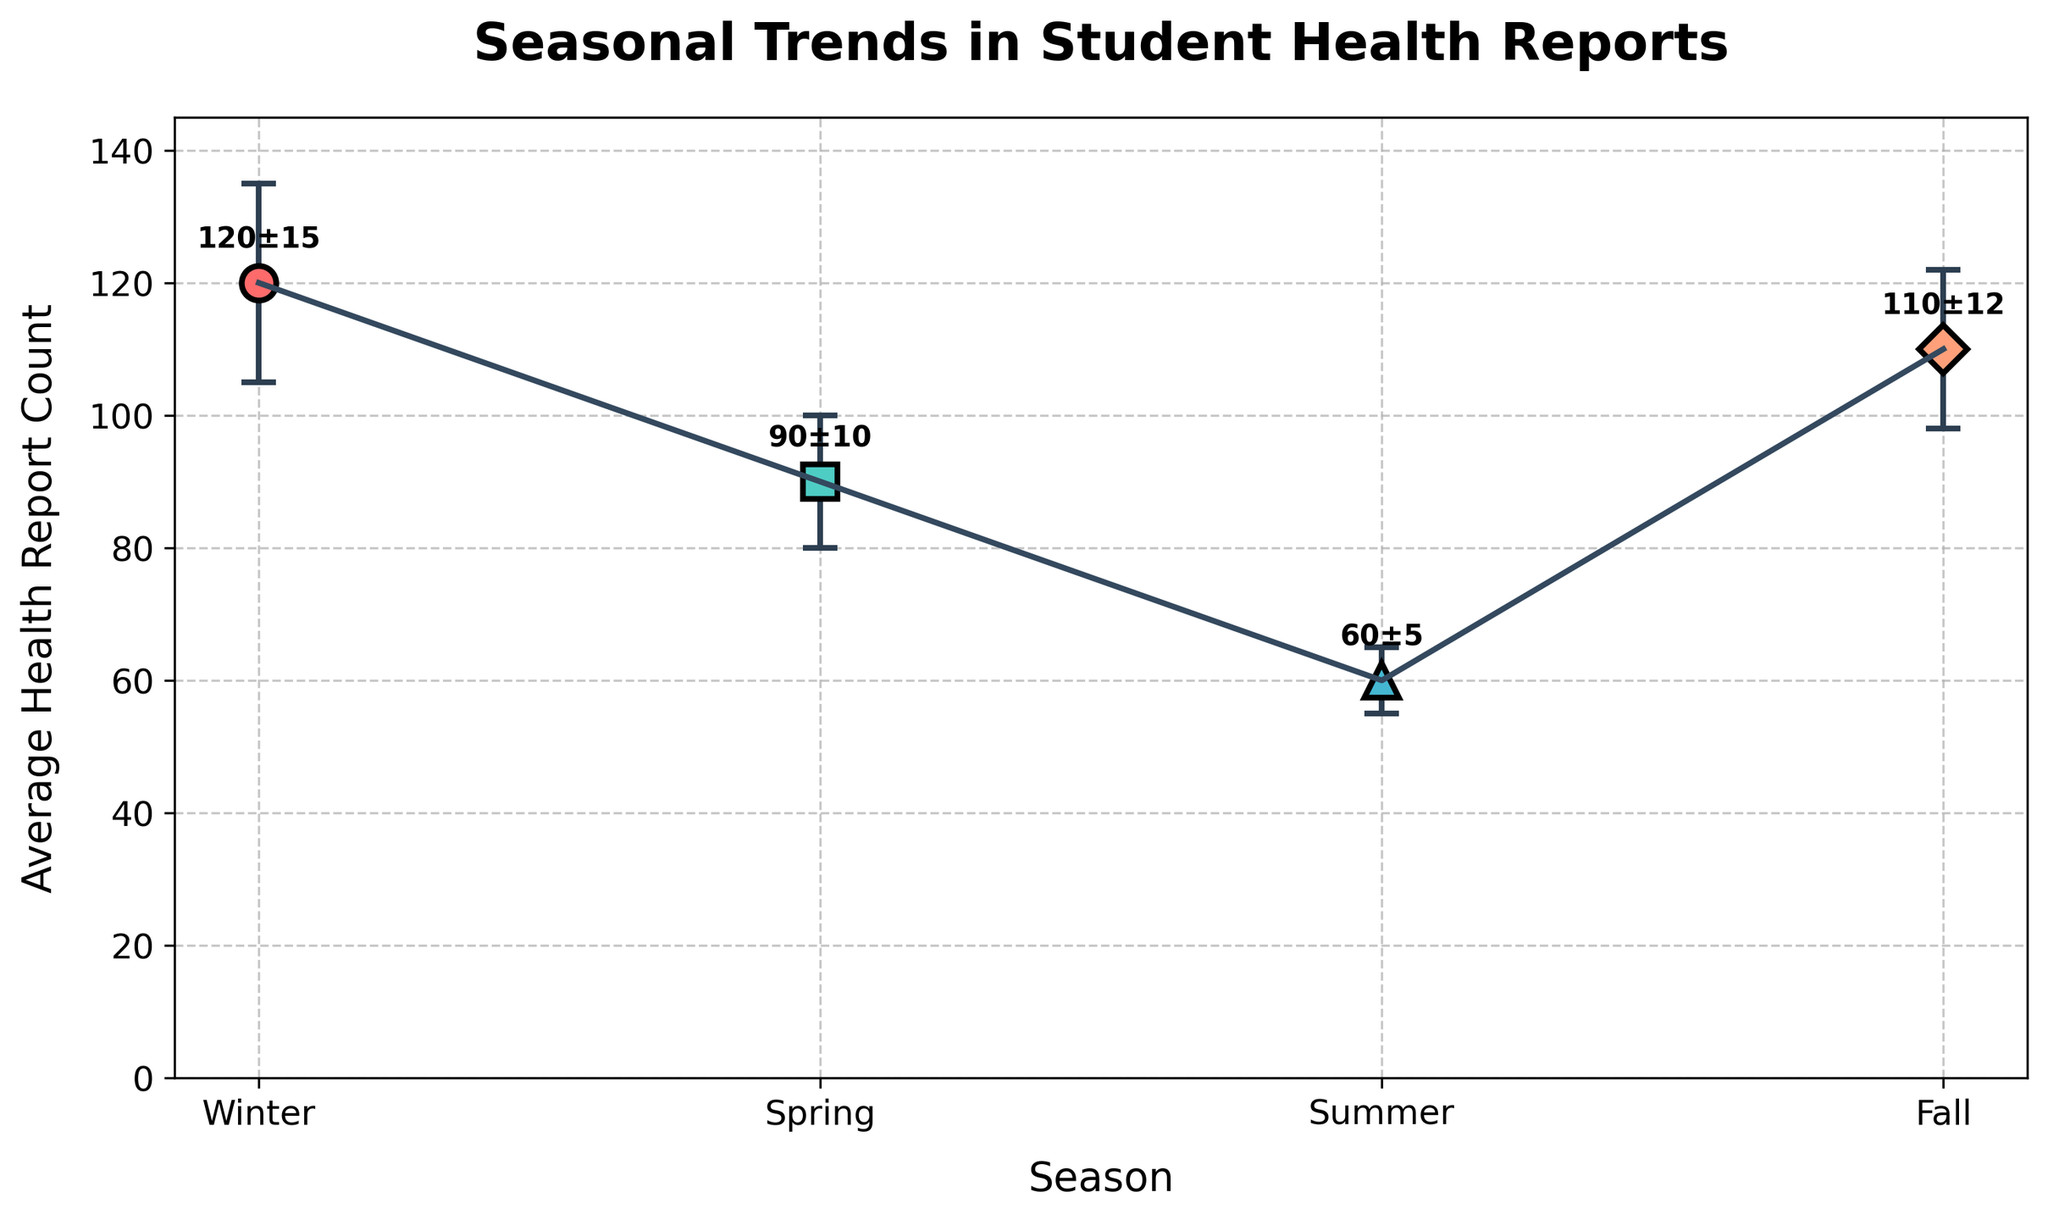What is the title of the figure? The title of the figure is usually located at the top, and in this case, it is "Seasonal Trends in Student Health Reports".
Answer: Seasonal Trends in Student Health Reports What season has the highest average health report count? By examining the points on the vertical axis, we see that Winter has the highest point at 120.
Answer: Winter How much variability (error bar) is there in the Spring season? The vertical error bar line coming from the Spring point indicates how much it varies, which is 10.
Answer: 10 Which season has the smallest average health report count? The lowest point on the vertical axis represents the season with the smallest count. For this plot, it is Summer at 60.
Answer: Summer Arrange the seasons in order of average health report count, from highest to lowest. By looking at the vertical positions of the points from top to bottom: Winter (120), Fall (110), Spring (90), Summer (60).
Answer: Winter, Fall, Spring, Summer What's the difference in the average health report count between Winter and Summer? Subtract the count of Summer (60) from the count of Winter (120). 120 - 60 = 60
Answer: 60 Which season has the greatest error bar? The height of the error bars indicates variability, and Winter's error bar is the tallest at 15.
Answer: Winter Is the variability generally high or low in Summer compared to other seasons? Compared to the other error bars, the Summer error bar is the shortest at 5, indicating lower variability.
Answer: Low Between Fall and Spring, which season has more variability in the health report count? By comparing the error bars, Fall has a variability of 12 and Spring has 10. Thus, Fall has more variability.
Answer: Fall Do average health report counts generally increase or decrease from Winter to Summer? Observing the trend line, the counts decrease from Winter to Summer.
Answer: Decrease 